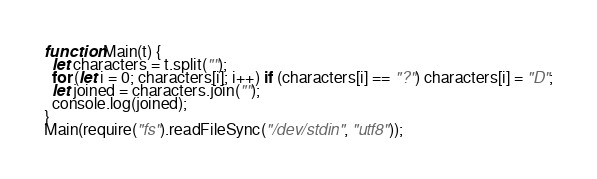<code> <loc_0><loc_0><loc_500><loc_500><_JavaScript_>function Main(t) {
  let characters = t.split("");
  for (let i = 0; characters[i]; i++) if (characters[i] == "?") characters[i] = "D";
  let joined = characters.join("");
  console.log(joined);
}  
Main(require("fs").readFileSync("/dev/stdin", "utf8"));
</code> 